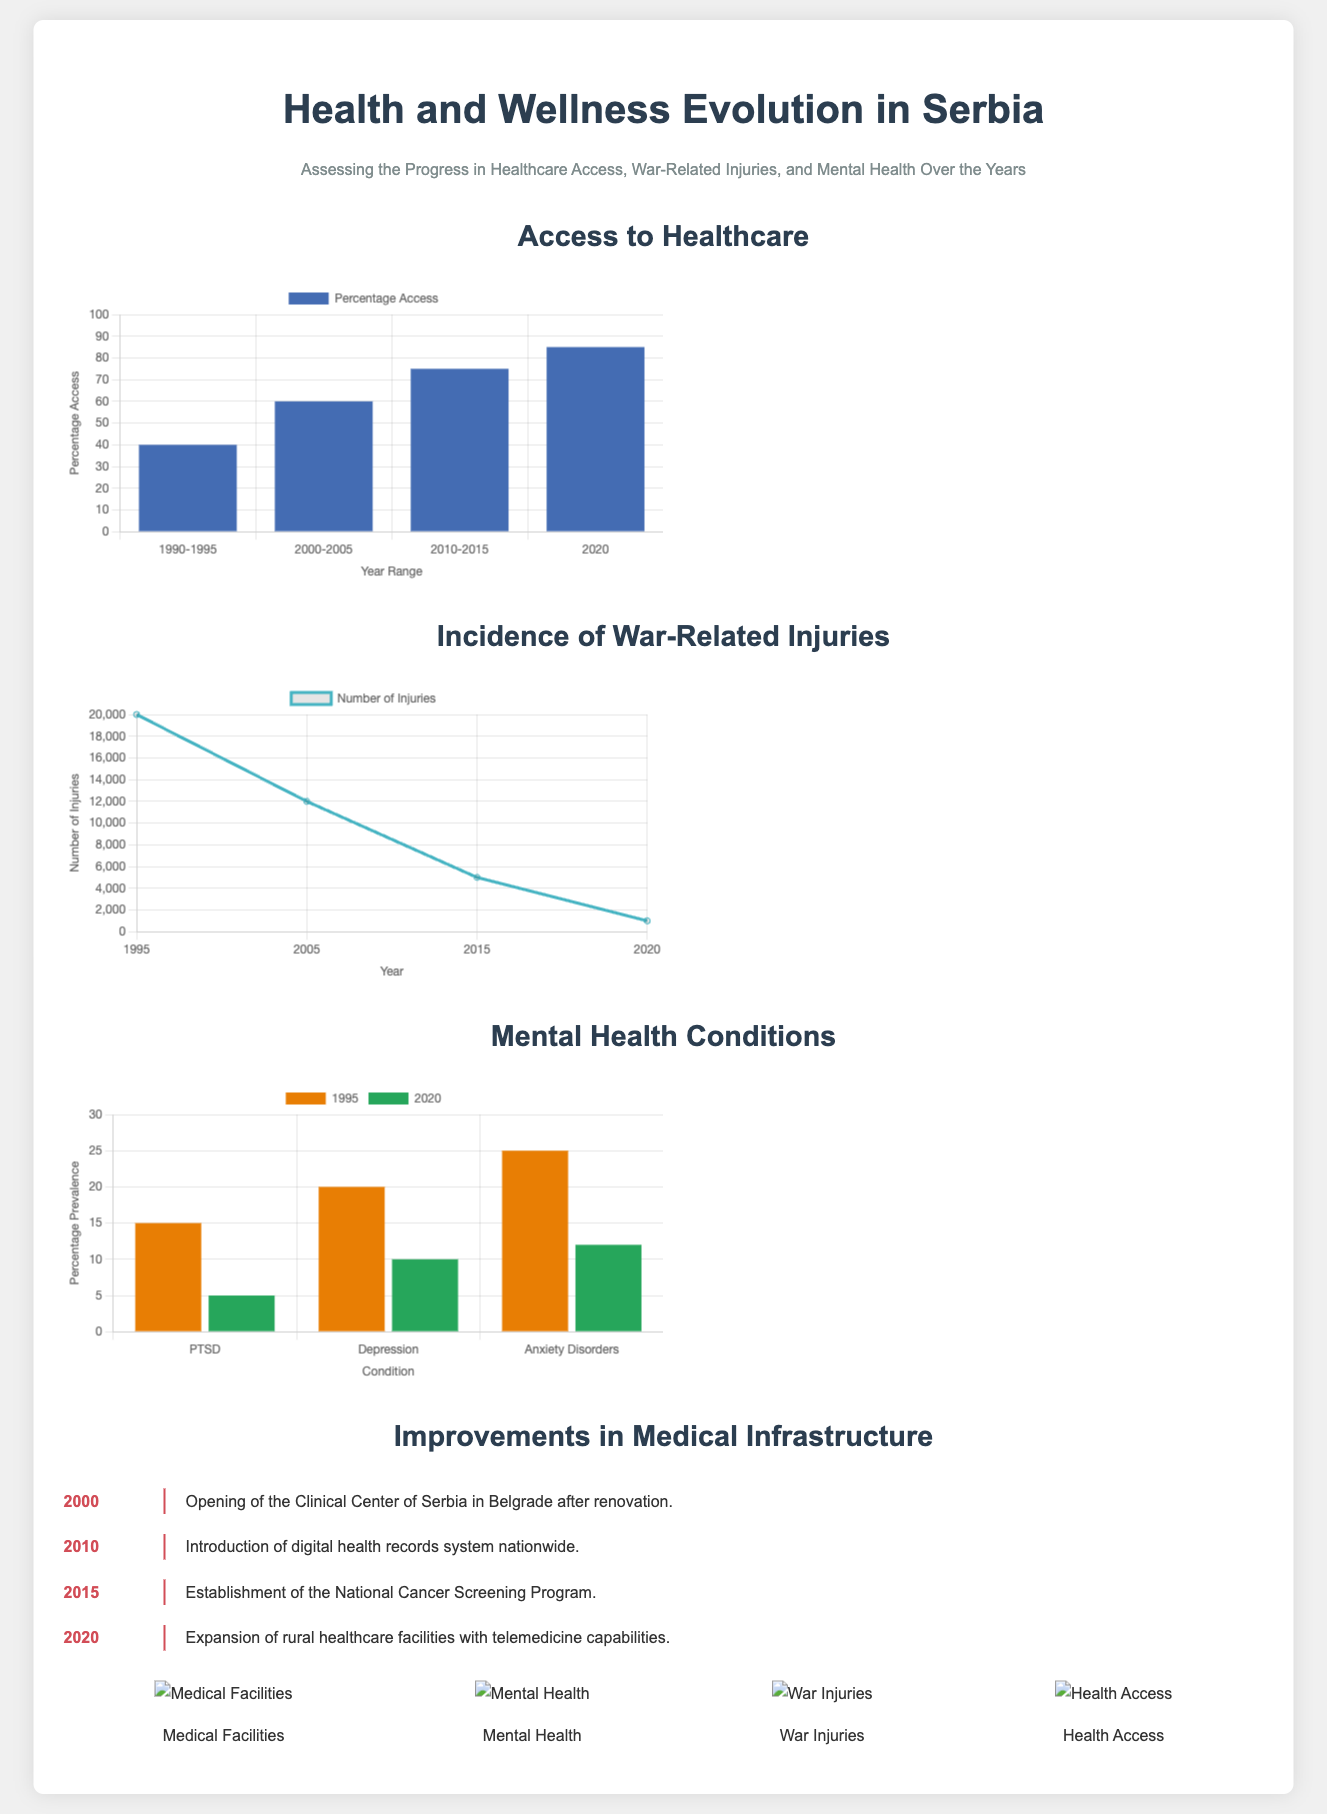What is the percentage access to healthcare in 2020? The percentage access to healthcare is stated in the document as 85% for the year 2020.
Answer: 85% What was the number of war-related injuries in 1995? The document states the number of injuries in 1995 was 20000.
Answer: 20000 Which year marks the opening of the Clinical Center of Serbia in Belgrade? The timeline indicates that the Clinical Center of Serbia was opened in 2000.
Answer: 2000 How many mental health conditions are reported in 1995? In 1995, three conditions were reported: PTSD, Depression, and Anxiety Disorders.
Answer: Three What was the percentage prevalence of PTSD in 1995? The document specifies that the prevalence of PTSD in 1995 was 15%.
Answer: 15% How has the number of injuries changed from 2005 to 2020? The number of injuries decreased from 12000 in 2005 to 1000 in 2020, indicating a significant reduction.
Answer: Significant reduction What improvement was introduced in 2010 regarding medical records? The document states that a digital health records system was introduced nationwide in 2010.
Answer: Digital health records system Which mental health condition shows the highest percentage prevalence in 1995? The condition with the highest percentage prevalence in 1995 was Anxiety Disorders at 25%.
Answer: Anxiety Disorders What year was the National Cancer Screening Program established? According to the timeline, the National Cancer Screening Program was established in 2015.
Answer: 2015 